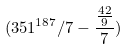Convert formula to latex. <formula><loc_0><loc_0><loc_500><loc_500>( 3 5 1 ^ { 1 8 7 } / 7 - \frac { \frac { 4 2 } { 9 } } { 7 } )</formula> 